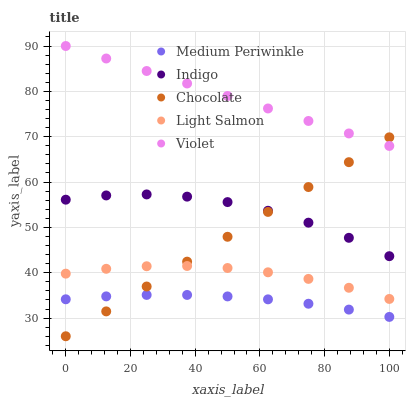Does Medium Periwinkle have the minimum area under the curve?
Answer yes or no. Yes. Does Violet have the maximum area under the curve?
Answer yes or no. Yes. Does Light Salmon have the minimum area under the curve?
Answer yes or no. No. Does Light Salmon have the maximum area under the curve?
Answer yes or no. No. Is Chocolate the smoothest?
Answer yes or no. Yes. Is Indigo the roughest?
Answer yes or no. Yes. Is Light Salmon the smoothest?
Answer yes or no. No. Is Light Salmon the roughest?
Answer yes or no. No. Does Chocolate have the lowest value?
Answer yes or no. Yes. Does Light Salmon have the lowest value?
Answer yes or no. No. Does Violet have the highest value?
Answer yes or no. Yes. Does Light Salmon have the highest value?
Answer yes or no. No. Is Medium Periwinkle less than Violet?
Answer yes or no. Yes. Is Violet greater than Light Salmon?
Answer yes or no. Yes. Does Chocolate intersect Light Salmon?
Answer yes or no. Yes. Is Chocolate less than Light Salmon?
Answer yes or no. No. Is Chocolate greater than Light Salmon?
Answer yes or no. No. Does Medium Periwinkle intersect Violet?
Answer yes or no. No. 